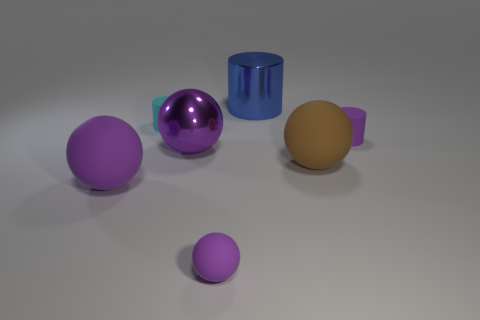Subtract all green cylinders. How many purple balls are left? 3 Subtract 1 balls. How many balls are left? 3 Add 1 brown matte blocks. How many objects exist? 8 Subtract all spheres. How many objects are left? 3 Subtract all small yellow rubber cubes. Subtract all large purple things. How many objects are left? 5 Add 4 big balls. How many big balls are left? 7 Add 1 big yellow shiny cylinders. How many big yellow shiny cylinders exist? 1 Subtract 0 gray balls. How many objects are left? 7 